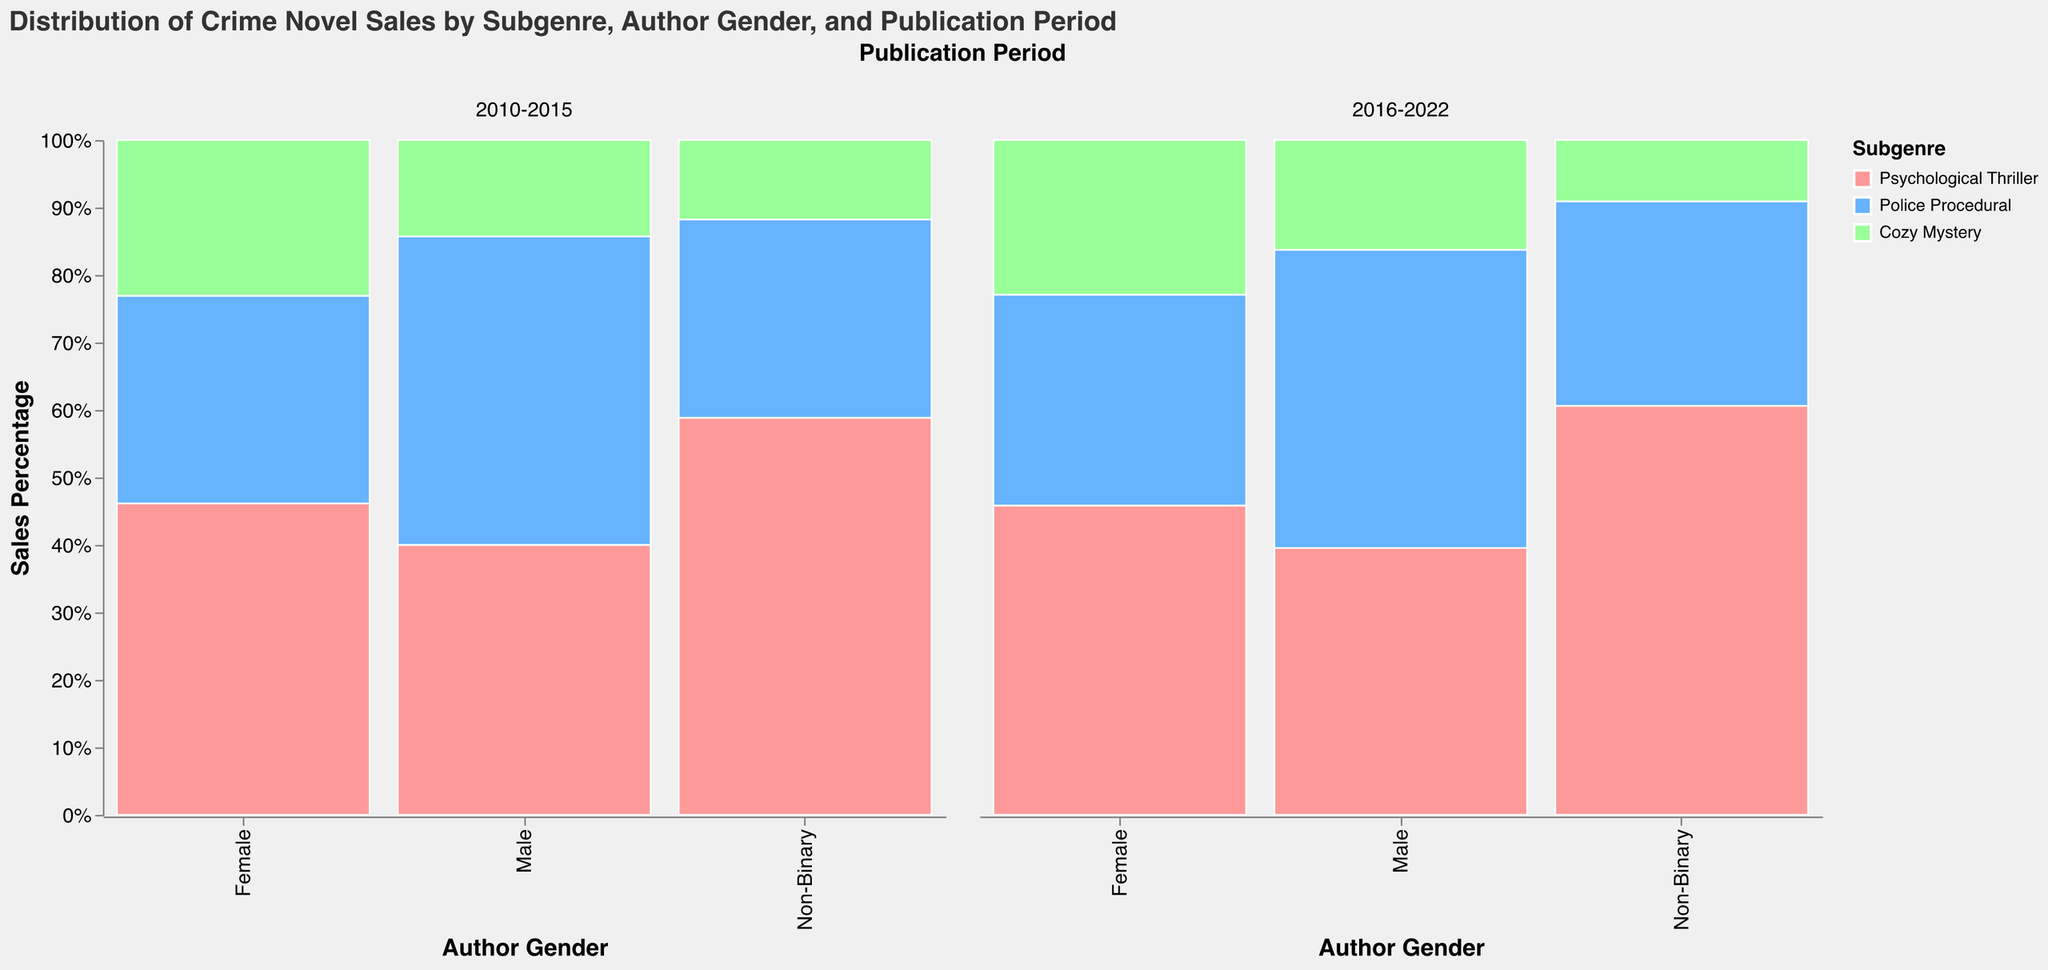What is the title of the figure? The title is clearly displayed at the top of the figure and reads: "Distribution of Crime Novel Sales by Subgenre, Author Gender, and Publication Period".
Answer: Distribution of Crime Novel Sales by Subgenre, Author Gender, and Publication Period Which author gender had the highest percentage of sales in the 2010-2015 period? Looking at the left column corresponding to the 2010-2015 period, we can see that the sales percentage bars for males are the highest collectively in this period.
Answer: Male How did the sales percentage for Female authors in the Psychological Thriller subgenre change from 2010-2015 to 2016-2022? The sales percentage for Female authors in the Psychological Thriller subgenre increased from 18% in 2010-2015 to 22% in 2016-2022.
Answer: Increased What is the color used for the Police Procedural subgenre? By referring to the legend in the figure, the Police Procedural subgenre is indicated with a light blue color.
Answer: Light blue Compare the percent of total sales for Male authors in the Cozy Mystery subgenre between the two publication periods. In 2010-2015, the sales percentage for Male authors in Cozy Mystery is 5%, while it increases to 7% in 2016-2022.
Answer: Increased from 5% to 7% What subgenre had the least percentage of sales for Non-Binary authors in the 2010-2015 period? By examining the relative height of the bars for Non-Binary authors in 2010-2015, it is evident that the Cozy Mystery subgenre had the lowest sales percentage of 0.2%.
Answer: Cozy Mystery What is the total percentage of sales for the Police Procedural subgenre across all author genders in the 2016-2022 period? Adding up the individual percentages for Police Procedural subgenre in 2016-2022 for all author genders (Female: 15%, Male: 19%, Non-Binary: 1%), the total percentage is 35%.
Answer: 35% Are the subgenre sales distributions more evenly spread among author genders in 2010-2015 or 2016-2022? In the 2010-2015 period, the distribution is more varied with larger differences between sales percentages for each gender across subgenres. In contrast, the 2016-2022 period shows a more balanced distribution with less drastic differences between the genders across different subgenres.
Answer: 2016-2022 